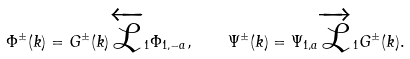<formula> <loc_0><loc_0><loc_500><loc_500>\Phi ^ { \pm } ( k ) = G ^ { \pm } ( k ) \overleftarrow { \mathcal { L } } _ { 1 } \Phi _ { 1 , - a } , \quad \Psi ^ { \pm } ( k ) = \Psi _ { 1 , a } \overrightarrow { \mathcal { L } } _ { 1 } G ^ { \pm } ( k ) .</formula> 